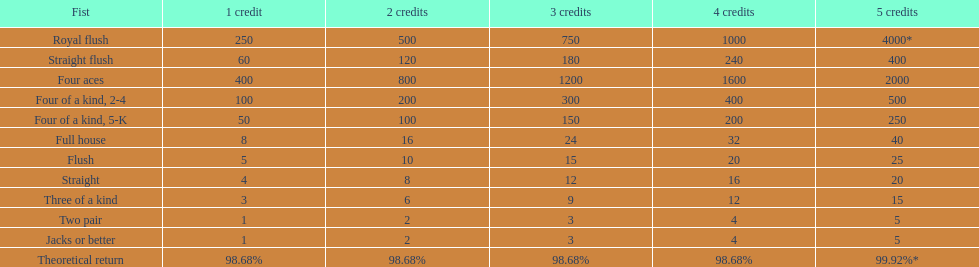Each four aces win is a multiple of what number? 400. Parse the table in full. {'header': ['Fist', '1 credit', '2 credits', '3 credits', '4 credits', '5 credits'], 'rows': [['Royal flush', '250', '500', '750', '1000', '4000*'], ['Straight flush', '60', '120', '180', '240', '400'], ['Four aces', '400', '800', '1200', '1600', '2000'], ['Four of a kind, 2-4', '100', '200', '300', '400', '500'], ['Four of a kind, 5-K', '50', '100', '150', '200', '250'], ['Full house', '8', '16', '24', '32', '40'], ['Flush', '5', '10', '15', '20', '25'], ['Straight', '4', '8', '12', '16', '20'], ['Three of a kind', '3', '6', '9', '12', '15'], ['Two pair', '1', '2', '3', '4', '5'], ['Jacks or better', '1', '2', '3', '4', '5'], ['Theoretical return', '98.68%', '98.68%', '98.68%', '98.68%', '99.92%*']]} 